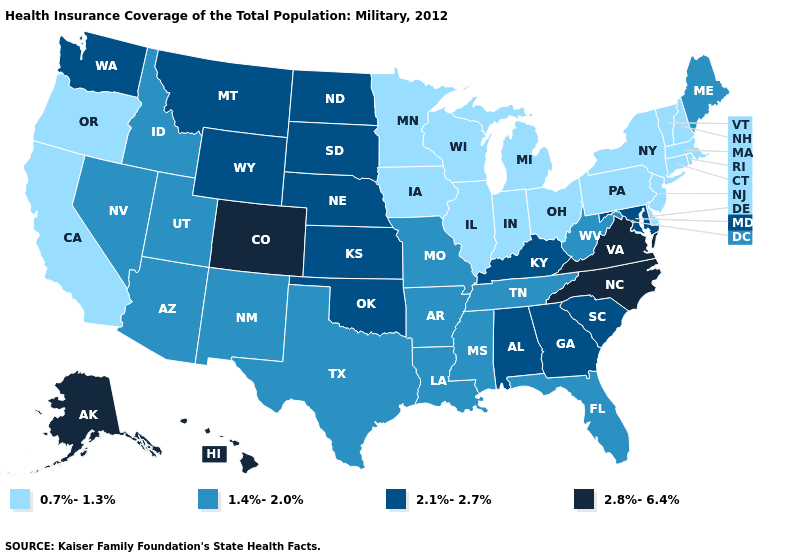What is the value of Ohio?
Quick response, please. 0.7%-1.3%. Does North Carolina have the highest value in the South?
Quick response, please. Yes. Name the states that have a value in the range 0.7%-1.3%?
Concise answer only. California, Connecticut, Delaware, Illinois, Indiana, Iowa, Massachusetts, Michigan, Minnesota, New Hampshire, New Jersey, New York, Ohio, Oregon, Pennsylvania, Rhode Island, Vermont, Wisconsin. What is the value of Kansas?
Give a very brief answer. 2.1%-2.7%. Name the states that have a value in the range 0.7%-1.3%?
Short answer required. California, Connecticut, Delaware, Illinois, Indiana, Iowa, Massachusetts, Michigan, Minnesota, New Hampshire, New Jersey, New York, Ohio, Oregon, Pennsylvania, Rhode Island, Vermont, Wisconsin. Which states have the lowest value in the USA?
Answer briefly. California, Connecticut, Delaware, Illinois, Indiana, Iowa, Massachusetts, Michigan, Minnesota, New Hampshire, New Jersey, New York, Ohio, Oregon, Pennsylvania, Rhode Island, Vermont, Wisconsin. Name the states that have a value in the range 0.7%-1.3%?
Give a very brief answer. California, Connecticut, Delaware, Illinois, Indiana, Iowa, Massachusetts, Michigan, Minnesota, New Hampshire, New Jersey, New York, Ohio, Oregon, Pennsylvania, Rhode Island, Vermont, Wisconsin. Among the states that border Kentucky , which have the highest value?
Short answer required. Virginia. Does Idaho have the lowest value in the West?
Quick response, please. No. What is the value of Montana?
Be succinct. 2.1%-2.7%. What is the lowest value in the West?
Be succinct. 0.7%-1.3%. What is the lowest value in the USA?
Concise answer only. 0.7%-1.3%. Name the states that have a value in the range 2.1%-2.7%?
Keep it brief. Alabama, Georgia, Kansas, Kentucky, Maryland, Montana, Nebraska, North Dakota, Oklahoma, South Carolina, South Dakota, Washington, Wyoming. Does North Carolina have the highest value in the South?
Answer briefly. Yes. What is the value of Wisconsin?
Concise answer only. 0.7%-1.3%. 